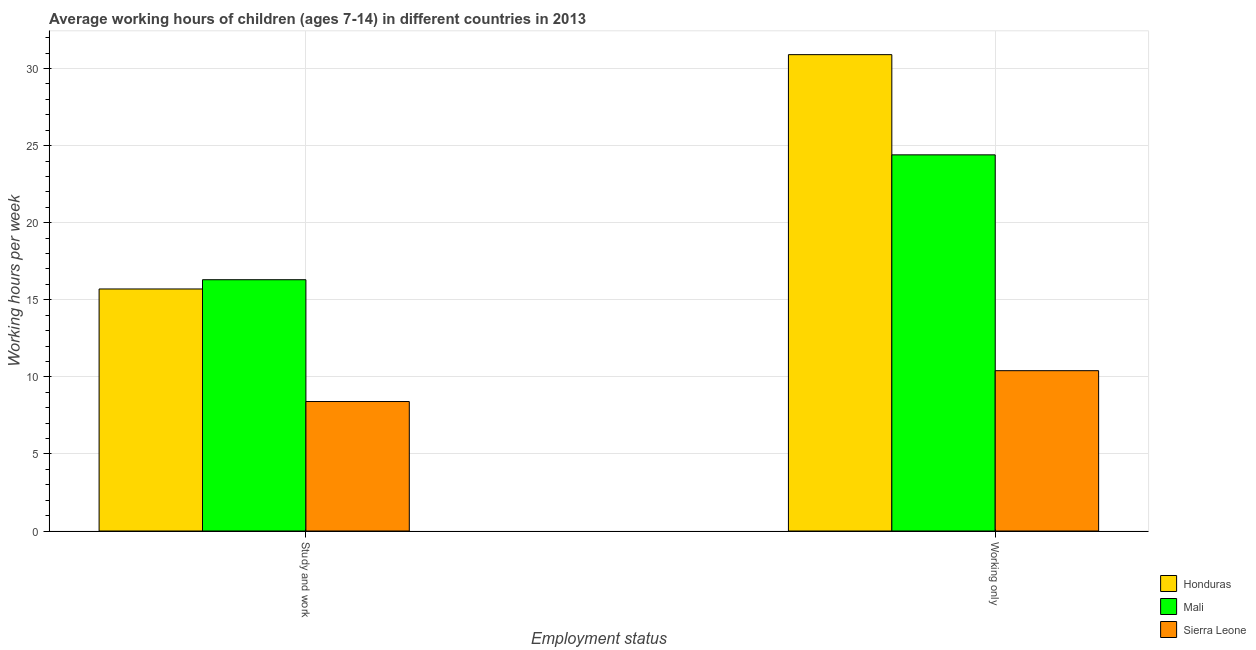Are the number of bars on each tick of the X-axis equal?
Your response must be concise. Yes. How many bars are there on the 2nd tick from the right?
Your answer should be compact. 3. What is the label of the 2nd group of bars from the left?
Offer a very short reply. Working only. What is the average working hour of children involved in only work in Honduras?
Provide a short and direct response. 30.9. Across all countries, what is the maximum average working hour of children involved in study and work?
Provide a succinct answer. 16.3. In which country was the average working hour of children involved in study and work maximum?
Ensure brevity in your answer.  Mali. In which country was the average working hour of children involved in study and work minimum?
Provide a short and direct response. Sierra Leone. What is the total average working hour of children involved in only work in the graph?
Give a very brief answer. 65.7. What is the difference between the average working hour of children involved in only work in Mali and that in Sierra Leone?
Offer a terse response. 14. What is the average average working hour of children involved in study and work per country?
Give a very brief answer. 13.47. What is the difference between the average working hour of children involved in only work and average working hour of children involved in study and work in Mali?
Offer a very short reply. 8.1. In how many countries, is the average working hour of children involved in only work greater than 30 hours?
Your answer should be very brief. 1. What is the ratio of the average working hour of children involved in study and work in Honduras to that in Mali?
Provide a short and direct response. 0.96. Is the average working hour of children involved in only work in Mali less than that in Sierra Leone?
Ensure brevity in your answer.  No. In how many countries, is the average working hour of children involved in only work greater than the average average working hour of children involved in only work taken over all countries?
Provide a succinct answer. 2. What does the 3rd bar from the left in Working only represents?
Make the answer very short. Sierra Leone. What does the 3rd bar from the right in Working only represents?
Offer a very short reply. Honduras. What is the difference between two consecutive major ticks on the Y-axis?
Make the answer very short. 5. Are the values on the major ticks of Y-axis written in scientific E-notation?
Provide a succinct answer. No. Does the graph contain grids?
Provide a short and direct response. Yes. How many legend labels are there?
Offer a very short reply. 3. How are the legend labels stacked?
Keep it short and to the point. Vertical. What is the title of the graph?
Offer a very short reply. Average working hours of children (ages 7-14) in different countries in 2013. Does "Peru" appear as one of the legend labels in the graph?
Offer a very short reply. No. What is the label or title of the X-axis?
Offer a very short reply. Employment status. What is the label or title of the Y-axis?
Your answer should be compact. Working hours per week. What is the Working hours per week of Mali in Study and work?
Provide a short and direct response. 16.3. What is the Working hours per week of Honduras in Working only?
Ensure brevity in your answer.  30.9. What is the Working hours per week of Mali in Working only?
Make the answer very short. 24.4. Across all Employment status, what is the maximum Working hours per week in Honduras?
Offer a very short reply. 30.9. Across all Employment status, what is the maximum Working hours per week in Mali?
Provide a short and direct response. 24.4. Across all Employment status, what is the maximum Working hours per week of Sierra Leone?
Your response must be concise. 10.4. Across all Employment status, what is the minimum Working hours per week of Mali?
Your response must be concise. 16.3. Across all Employment status, what is the minimum Working hours per week in Sierra Leone?
Your response must be concise. 8.4. What is the total Working hours per week of Honduras in the graph?
Your answer should be very brief. 46.6. What is the total Working hours per week of Mali in the graph?
Keep it short and to the point. 40.7. What is the total Working hours per week in Sierra Leone in the graph?
Give a very brief answer. 18.8. What is the difference between the Working hours per week in Honduras in Study and work and that in Working only?
Keep it short and to the point. -15.2. What is the difference between the Working hours per week of Mali in Study and work and that in Working only?
Keep it short and to the point. -8.1. What is the difference between the Working hours per week of Sierra Leone in Study and work and that in Working only?
Give a very brief answer. -2. What is the difference between the Working hours per week in Honduras in Study and work and the Working hours per week in Mali in Working only?
Your response must be concise. -8.7. What is the difference between the Working hours per week of Honduras in Study and work and the Working hours per week of Sierra Leone in Working only?
Ensure brevity in your answer.  5.3. What is the difference between the Working hours per week of Mali in Study and work and the Working hours per week of Sierra Leone in Working only?
Make the answer very short. 5.9. What is the average Working hours per week of Honduras per Employment status?
Ensure brevity in your answer.  23.3. What is the average Working hours per week of Mali per Employment status?
Provide a succinct answer. 20.35. What is the average Working hours per week in Sierra Leone per Employment status?
Provide a short and direct response. 9.4. What is the difference between the Working hours per week of Honduras and Working hours per week of Mali in Study and work?
Provide a succinct answer. -0.6. What is the difference between the Working hours per week of Honduras and Working hours per week of Sierra Leone in Study and work?
Ensure brevity in your answer.  7.3. What is the difference between the Working hours per week in Mali and Working hours per week in Sierra Leone in Study and work?
Keep it short and to the point. 7.9. What is the difference between the Working hours per week of Honduras and Working hours per week of Mali in Working only?
Your answer should be very brief. 6.5. What is the difference between the Working hours per week in Honduras and Working hours per week in Sierra Leone in Working only?
Make the answer very short. 20.5. What is the ratio of the Working hours per week of Honduras in Study and work to that in Working only?
Provide a short and direct response. 0.51. What is the ratio of the Working hours per week in Mali in Study and work to that in Working only?
Make the answer very short. 0.67. What is the ratio of the Working hours per week in Sierra Leone in Study and work to that in Working only?
Your response must be concise. 0.81. What is the difference between the highest and the second highest Working hours per week in Honduras?
Keep it short and to the point. 15.2. 